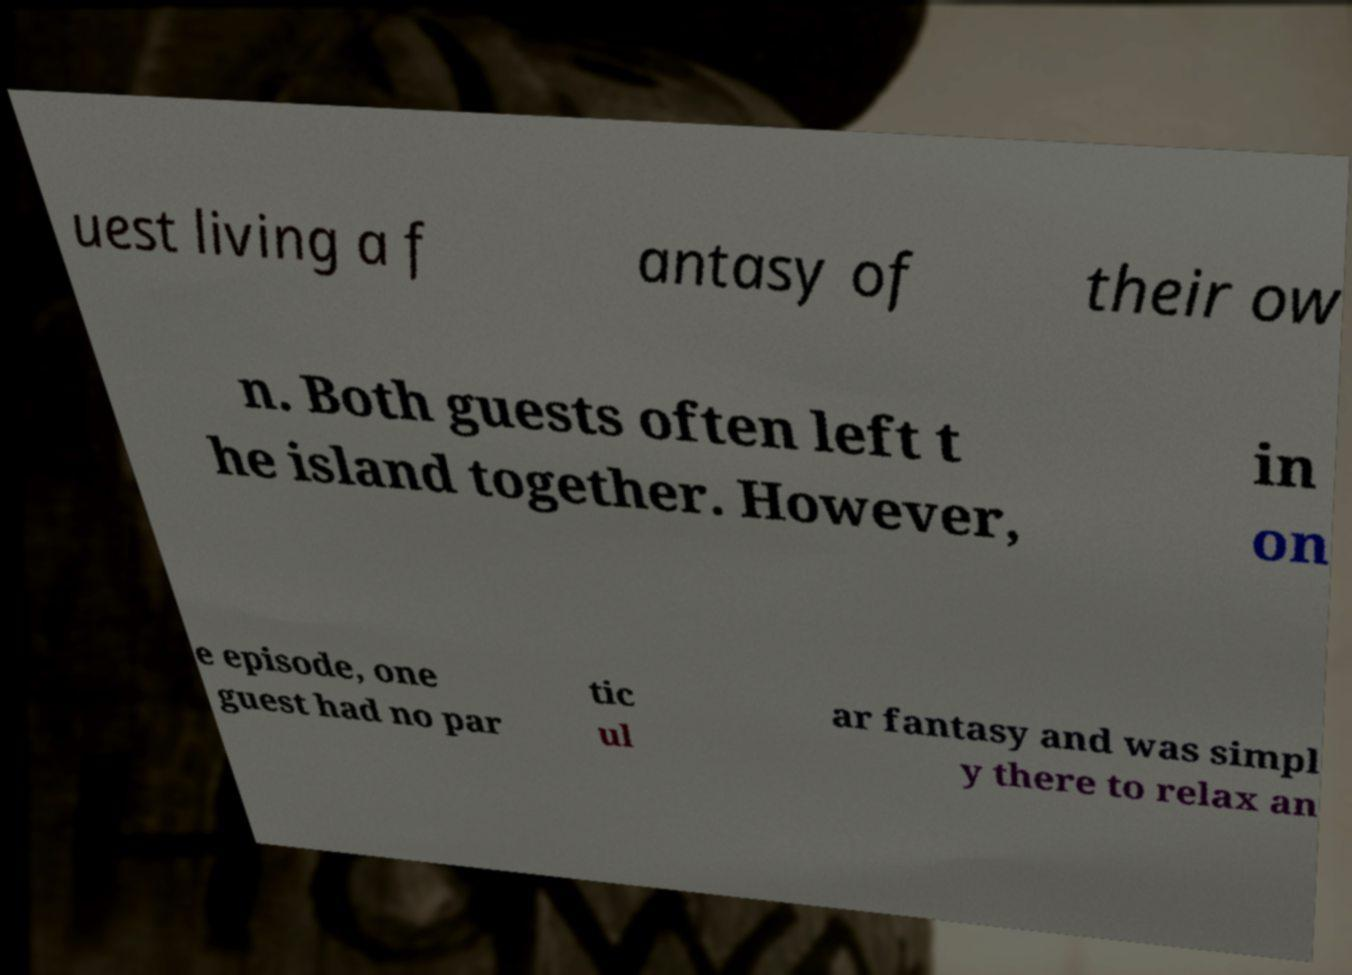For documentation purposes, I need the text within this image transcribed. Could you provide that? uest living a f antasy of their ow n. Both guests often left t he island together. However, in on e episode, one guest had no par tic ul ar fantasy and was simpl y there to relax an 